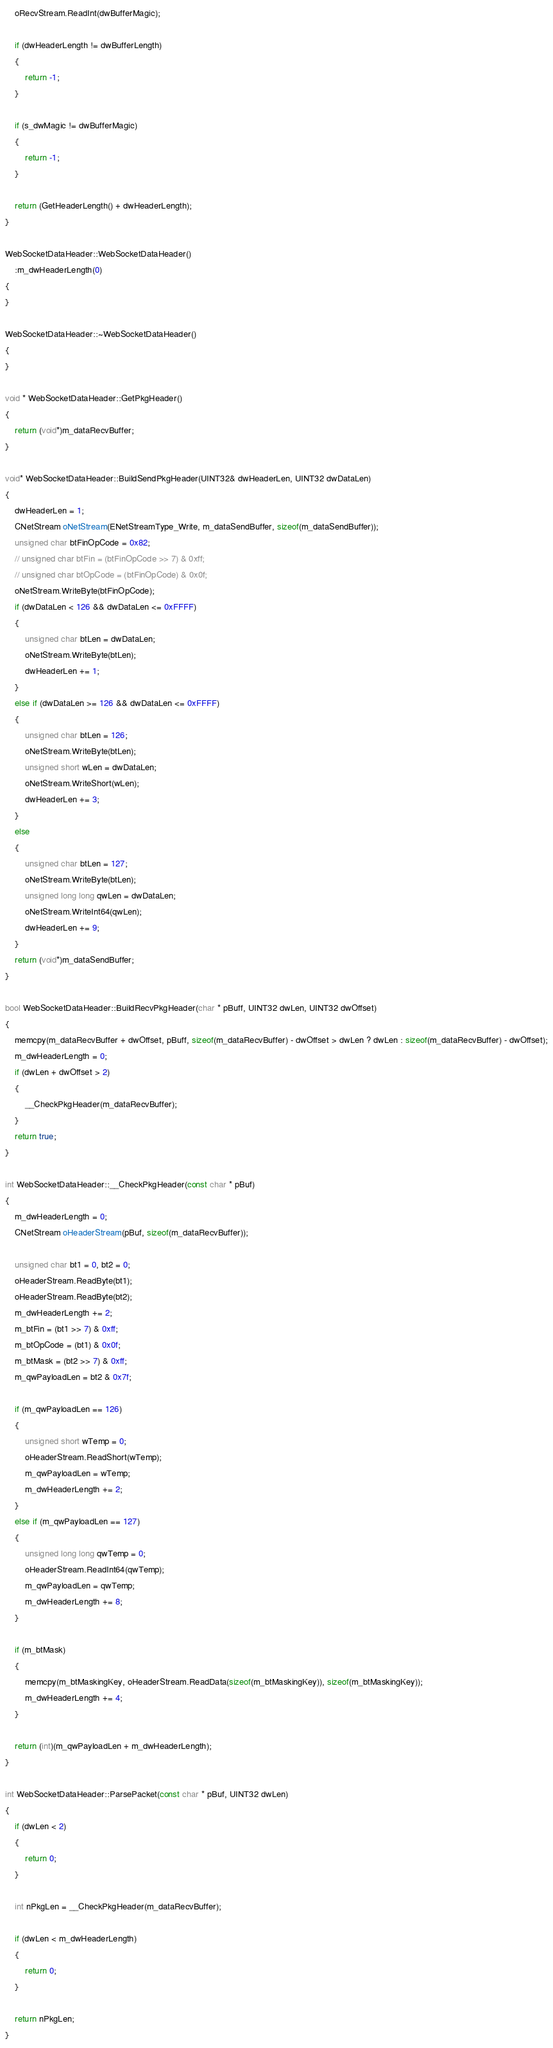<code> <loc_0><loc_0><loc_500><loc_500><_C++_>	oRecvStream.ReadInt(dwBufferMagic);

	if (dwHeaderLength != dwBufferLength)
	{
		return -1;
	}

	if (s_dwMagic != dwBufferMagic)
	{
		return -1;
	}

	return (GetHeaderLength() + dwHeaderLength);
}

WebSocketDataHeader::WebSocketDataHeader()
	:m_dwHeaderLength(0)
{
}

WebSocketDataHeader::~WebSocketDataHeader()
{
}

void * WebSocketDataHeader::GetPkgHeader()
{
	return (void*)m_dataRecvBuffer;
}

void* WebSocketDataHeader::BuildSendPkgHeader(UINT32& dwHeaderLen, UINT32 dwDataLen)
{
	dwHeaderLen = 1;
	CNetStream oNetStream(ENetStreamType_Write, m_dataSendBuffer, sizeof(m_dataSendBuffer));
	unsigned char btFinOpCode = 0x82;
	// unsigned char btFin = (btFinOpCode >> 7) & 0xff;
	// unsigned char btOpCode = (btFinOpCode) & 0x0f;
	oNetStream.WriteByte(btFinOpCode);
	if (dwDataLen < 126 && dwDataLen <= 0xFFFF)
	{
		unsigned char btLen = dwDataLen;
		oNetStream.WriteByte(btLen);
		dwHeaderLen += 1;
	}
	else if (dwDataLen >= 126 && dwDataLen <= 0xFFFF)
	{
		unsigned char btLen = 126;
		oNetStream.WriteByte(btLen);
		unsigned short wLen = dwDataLen;
		oNetStream.WriteShort(wLen);
		dwHeaderLen += 3;
	}
	else
	{
		unsigned char btLen = 127;
		oNetStream.WriteByte(btLen);
		unsigned long long qwLen = dwDataLen;
		oNetStream.WriteInt64(qwLen);
		dwHeaderLen += 9;
	}
	return (void*)m_dataSendBuffer;
}

bool WebSocketDataHeader::BuildRecvPkgHeader(char * pBuff, UINT32 dwLen, UINT32 dwOffset)
{
	memcpy(m_dataRecvBuffer + dwOffset, pBuff, sizeof(m_dataRecvBuffer) - dwOffset > dwLen ? dwLen : sizeof(m_dataRecvBuffer) - dwOffset);
	m_dwHeaderLength = 0;
	if (dwLen + dwOffset > 2)
	{
		__CheckPkgHeader(m_dataRecvBuffer);
	}
	return true;
}

int WebSocketDataHeader::__CheckPkgHeader(const char * pBuf)
{
	m_dwHeaderLength = 0;
	CNetStream oHeaderStream(pBuf, sizeof(m_dataRecvBuffer));
	
	unsigned char bt1 = 0, bt2 = 0;
	oHeaderStream.ReadByte(bt1);
	oHeaderStream.ReadByte(bt2);
	m_dwHeaderLength += 2;
	m_btFin = (bt1 >> 7) & 0xff;
	m_btOpCode = (bt1) & 0x0f;
	m_btMask = (bt2 >> 7) & 0xff;
	m_qwPayloadLen = bt2 & 0x7f;

	if (m_qwPayloadLen == 126)
	{
		unsigned short wTemp = 0;
		oHeaderStream.ReadShort(wTemp);
		m_qwPayloadLen = wTemp;
		m_dwHeaderLength += 2;
	}
	else if (m_qwPayloadLen == 127)
	{
		unsigned long long qwTemp = 0;
		oHeaderStream.ReadInt64(qwTemp);
		m_qwPayloadLen = qwTemp;
		m_dwHeaderLength += 8;
	}
	
	if (m_btMask)
	{
		memcpy(m_btMaskingKey, oHeaderStream.ReadData(sizeof(m_btMaskingKey)), sizeof(m_btMaskingKey));
		m_dwHeaderLength += 4;
	}

	return (int)(m_qwPayloadLen + m_dwHeaderLength);
}

int WebSocketDataHeader::ParsePacket(const char * pBuf, UINT32 dwLen)
{
	if (dwLen < 2)
	{
		return 0;
	}

	int nPkgLen = __CheckPkgHeader(m_dataRecvBuffer);

	if (dwLen < m_dwHeaderLength)
	{
		return 0;
	}

	return nPkgLen;
}

</code> 